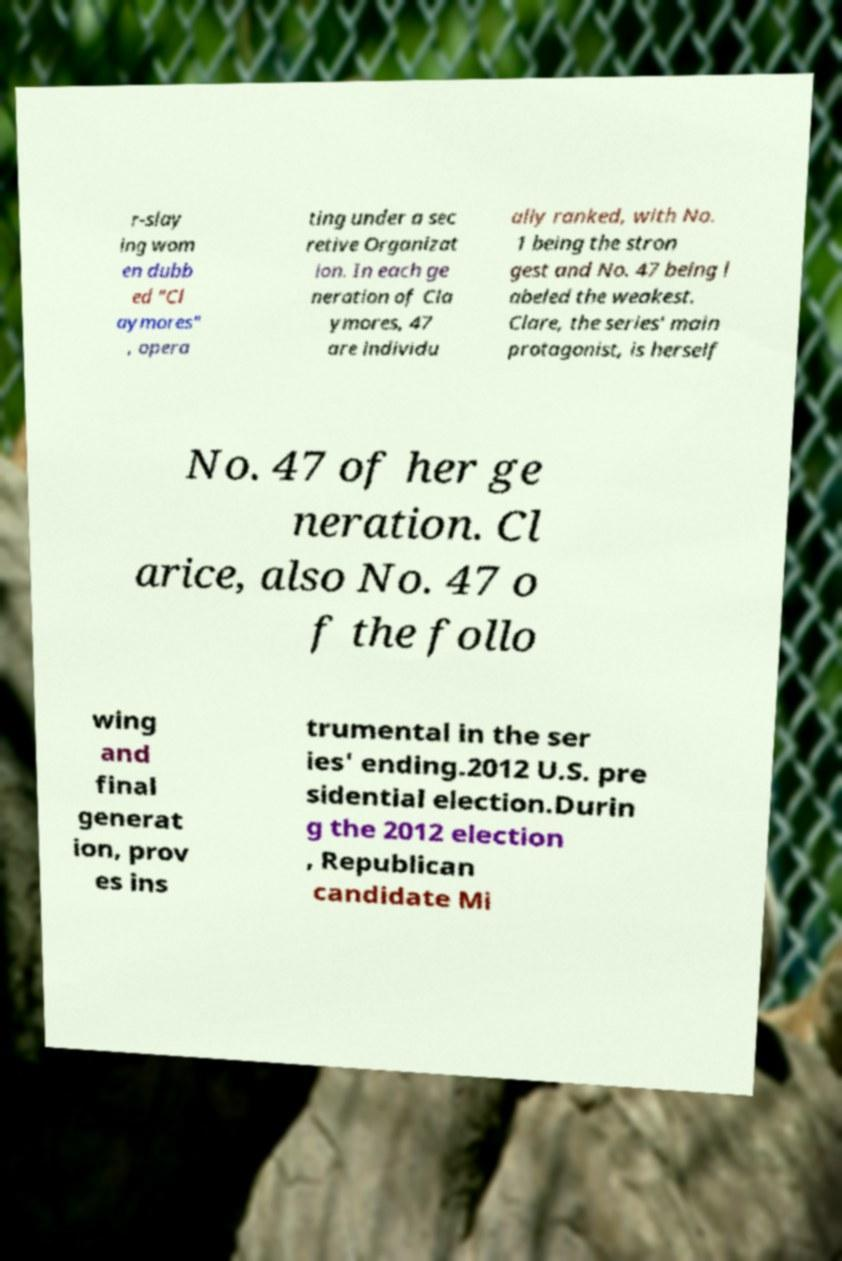There's text embedded in this image that I need extracted. Can you transcribe it verbatim? r-slay ing wom en dubb ed "Cl aymores" , opera ting under a sec retive Organizat ion. In each ge neration of Cla ymores, 47 are individu ally ranked, with No. 1 being the stron gest and No. 47 being l abeled the weakest. Clare, the series' main protagonist, is herself No. 47 of her ge neration. Cl arice, also No. 47 o f the follo wing and final generat ion, prov es ins trumental in the ser ies' ending.2012 U.S. pre sidential election.Durin g the 2012 election , Republican candidate Mi 